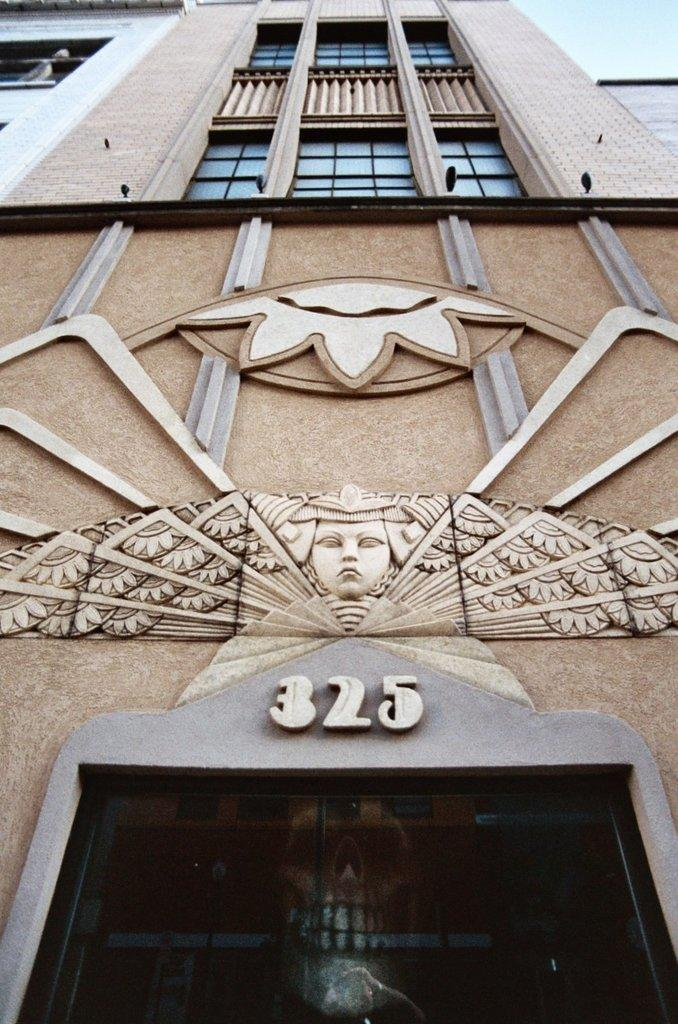What is the main structure visible in the image? There is a building in the image. What can be seen on the building? There are arts on the building. Are there any pets visible in the image? There is no mention of pets in the provided facts, and therefore no pets can be seen in the image. 